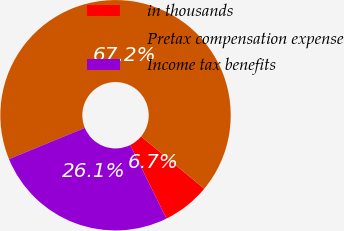Convert chart. <chart><loc_0><loc_0><loc_500><loc_500><pie_chart><fcel>in thousands<fcel>Pretax compensation expense<fcel>Income tax benefits<nl><fcel>6.7%<fcel>67.22%<fcel>26.08%<nl></chart> 